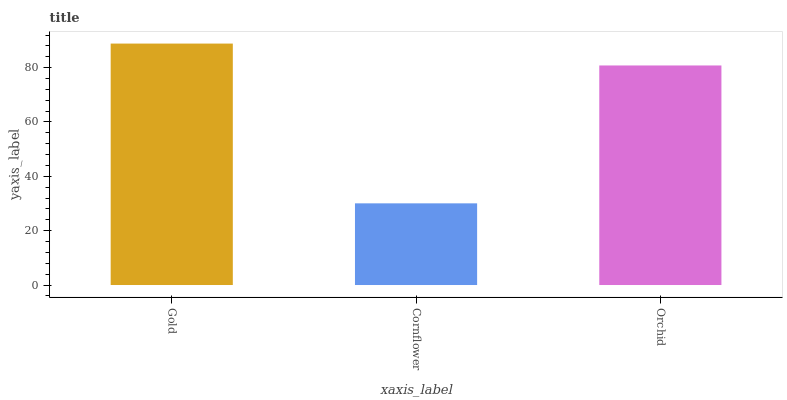Is Orchid the minimum?
Answer yes or no. No. Is Orchid the maximum?
Answer yes or no. No. Is Orchid greater than Cornflower?
Answer yes or no. Yes. Is Cornflower less than Orchid?
Answer yes or no. Yes. Is Cornflower greater than Orchid?
Answer yes or no. No. Is Orchid less than Cornflower?
Answer yes or no. No. Is Orchid the high median?
Answer yes or no. Yes. Is Orchid the low median?
Answer yes or no. Yes. Is Cornflower the high median?
Answer yes or no. No. Is Cornflower the low median?
Answer yes or no. No. 